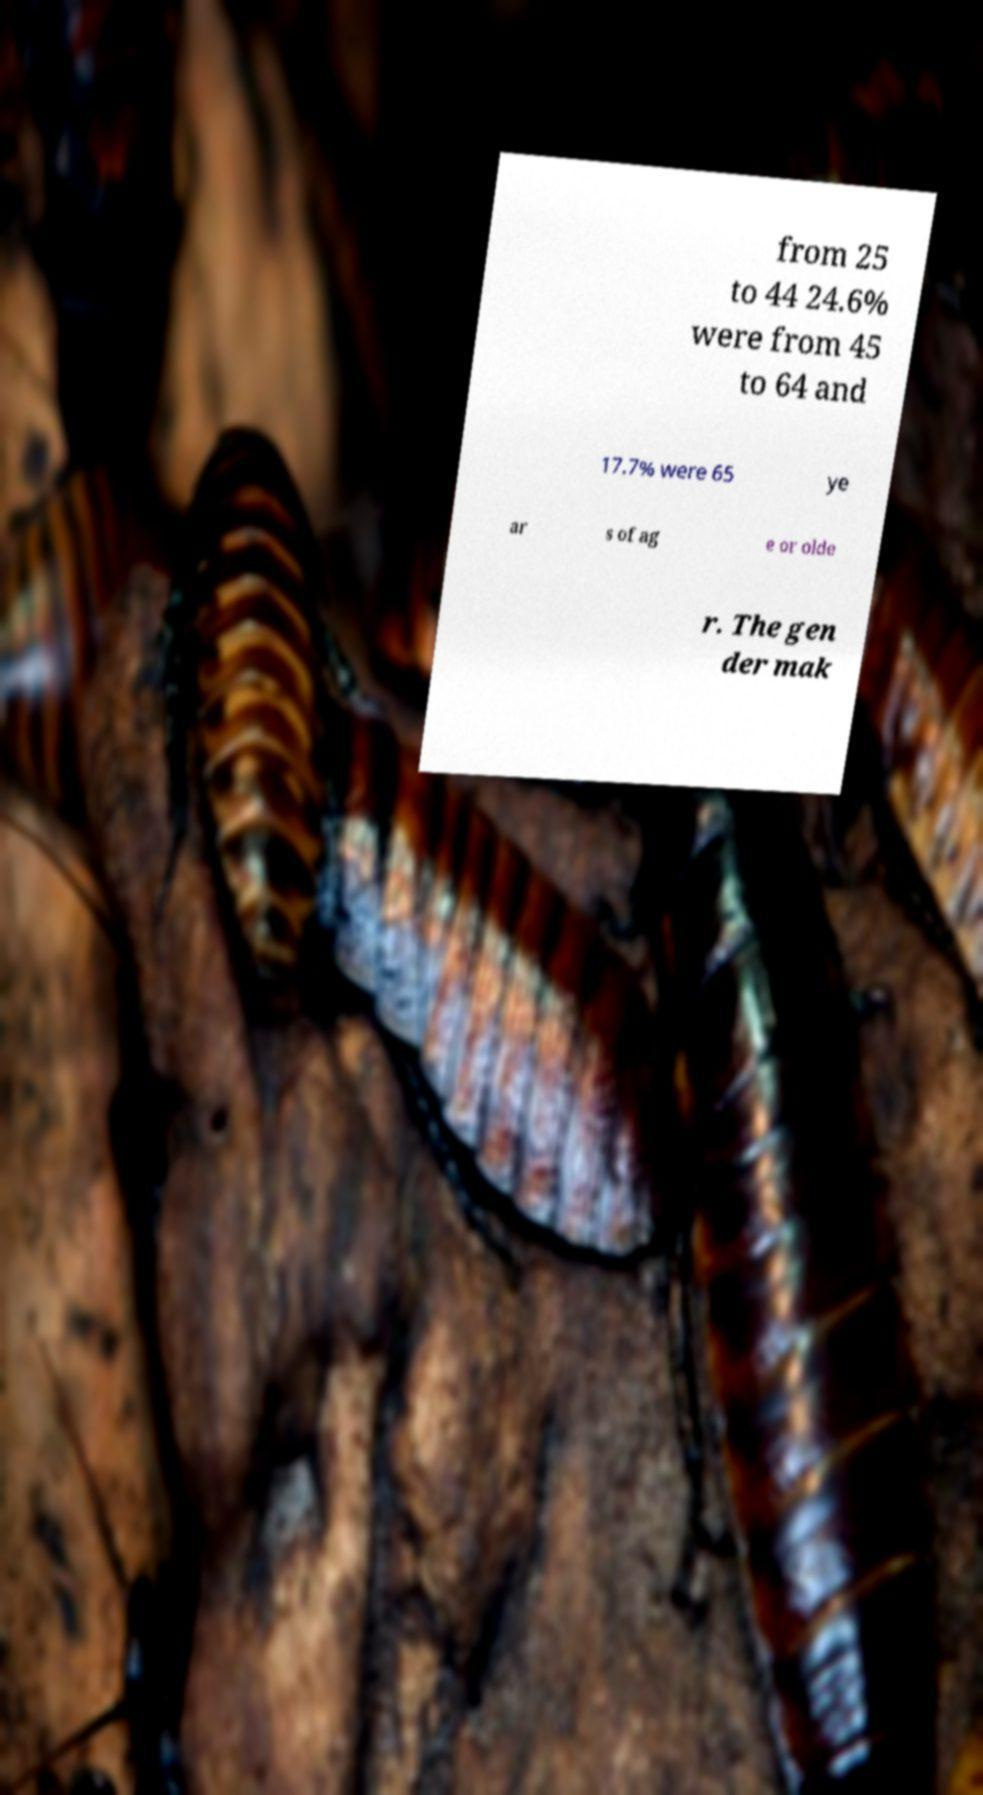For documentation purposes, I need the text within this image transcribed. Could you provide that? from 25 to 44 24.6% were from 45 to 64 and 17.7% were 65 ye ar s of ag e or olde r. The gen der mak 